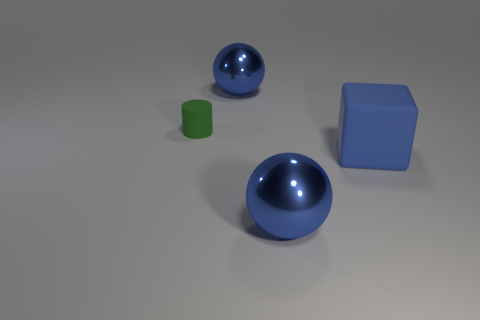Is the blue cube the same size as the matte cylinder?
Make the answer very short. No. How many things are green matte objects that are behind the cube or big shiny spheres in front of the cylinder?
Offer a very short reply. 2. There is a big metal sphere in front of the blue shiny object that is behind the blue block; how many big blue rubber cubes are behind it?
Your response must be concise. 1. There is a ball that is in front of the matte block; what is its size?
Make the answer very short. Large. What number of cylinders have the same size as the green thing?
Your answer should be compact. 0. Is the size of the blue rubber cube the same as the blue metal sphere that is behind the green cylinder?
Provide a succinct answer. Yes. What number of objects are either matte cylinders or blue rubber cubes?
Provide a succinct answer. 2. How many spheres are the same color as the large block?
Give a very brief answer. 2. Is there a big metal object of the same shape as the tiny green matte object?
Your answer should be compact. No. How many other big blocks are the same material as the big cube?
Provide a short and direct response. 0. 